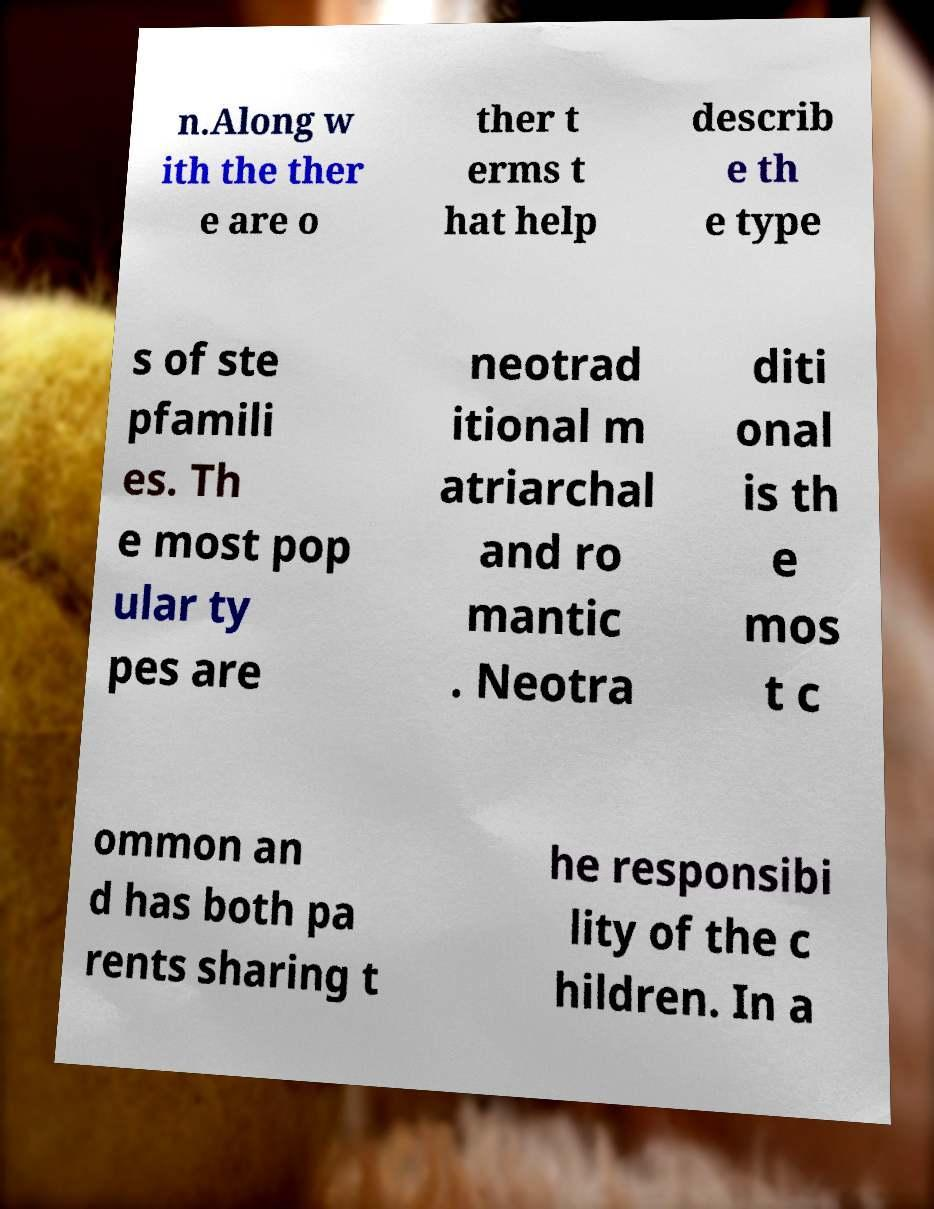Could you extract and type out the text from this image? n.Along w ith the ther e are o ther t erms t hat help describ e th e type s of ste pfamili es. Th e most pop ular ty pes are neotrad itional m atriarchal and ro mantic . Neotra diti onal is th e mos t c ommon an d has both pa rents sharing t he responsibi lity of the c hildren. In a 